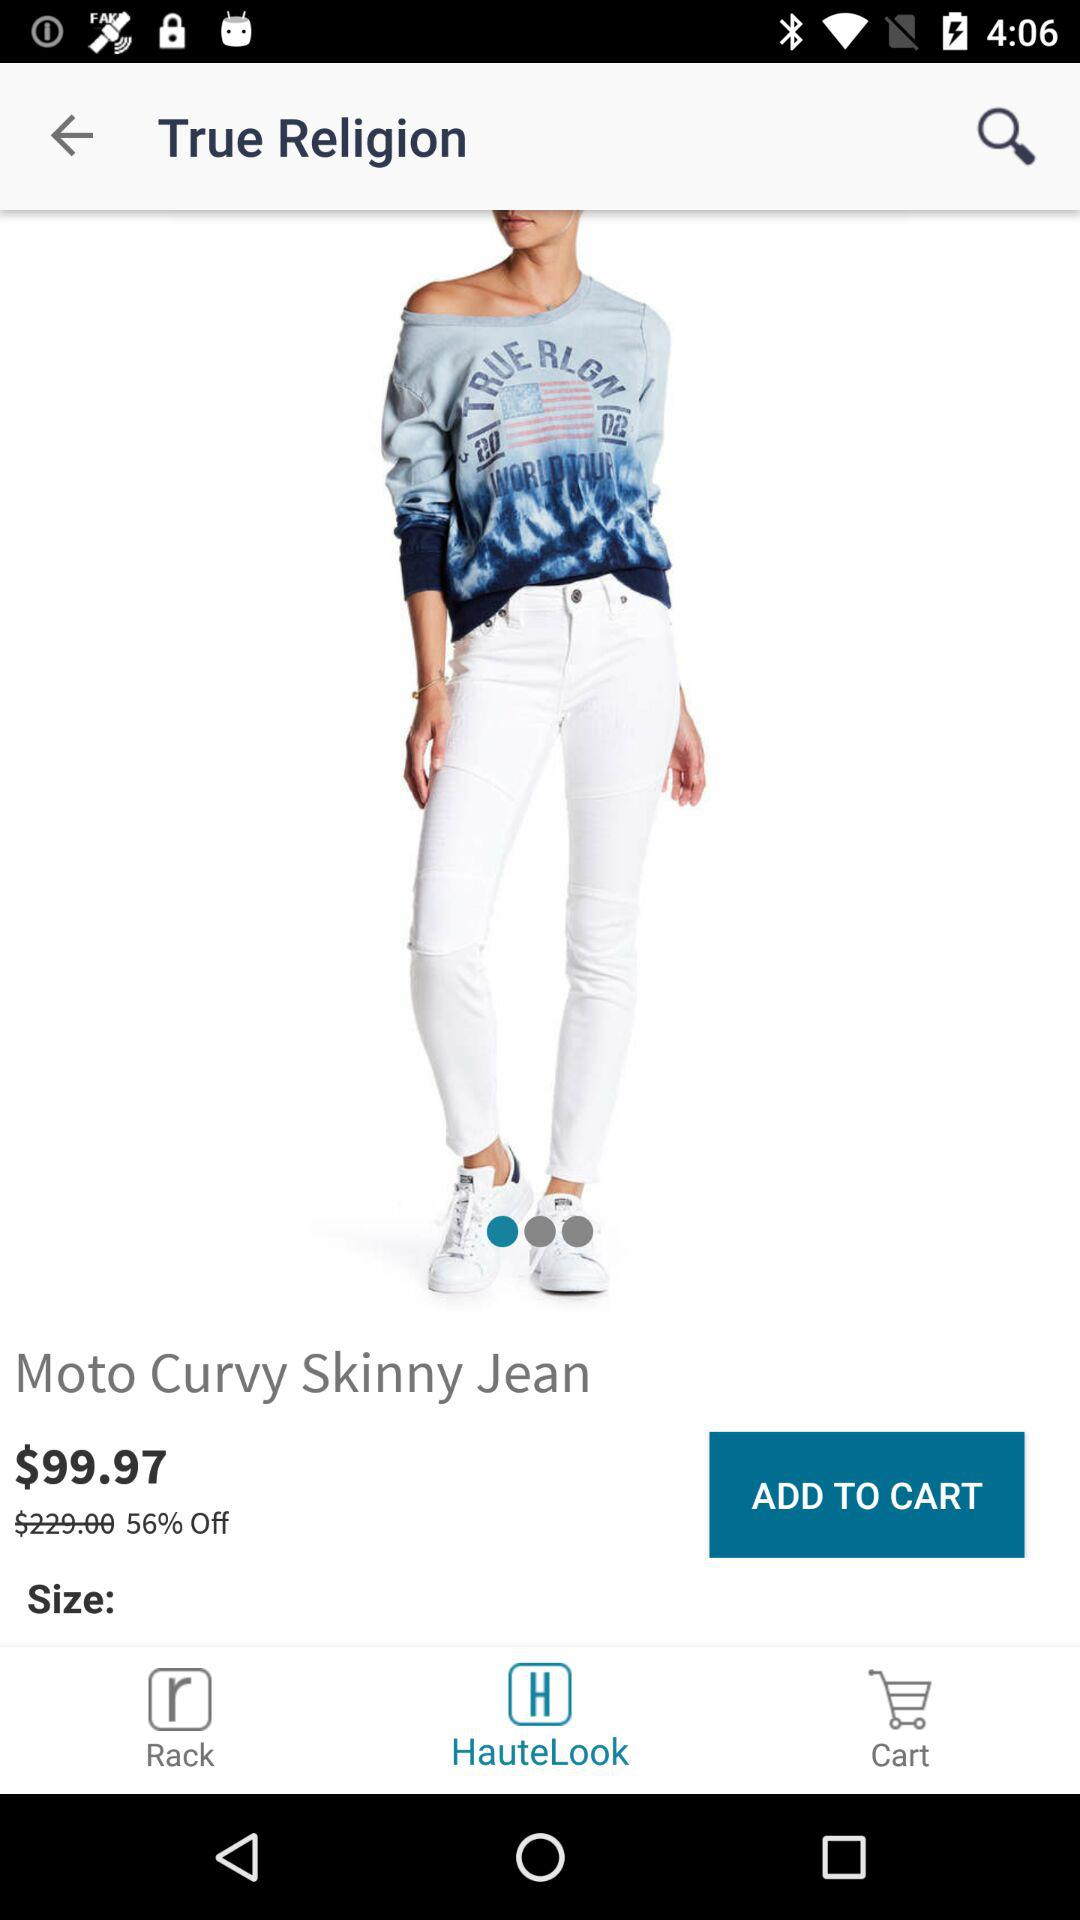What is the percentage discount on the jeans?
Answer the question using a single word or phrase. 56% 